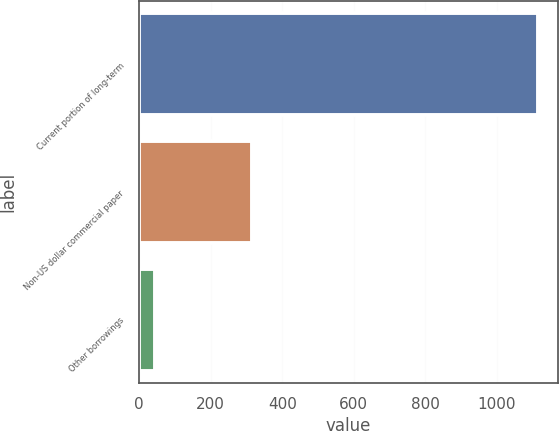Convert chart. <chart><loc_0><loc_0><loc_500><loc_500><bar_chart><fcel>Current portion of long-term<fcel>Non-US dollar commercial paper<fcel>Other borrowings<nl><fcel>1114<fcel>314<fcel>43<nl></chart> 